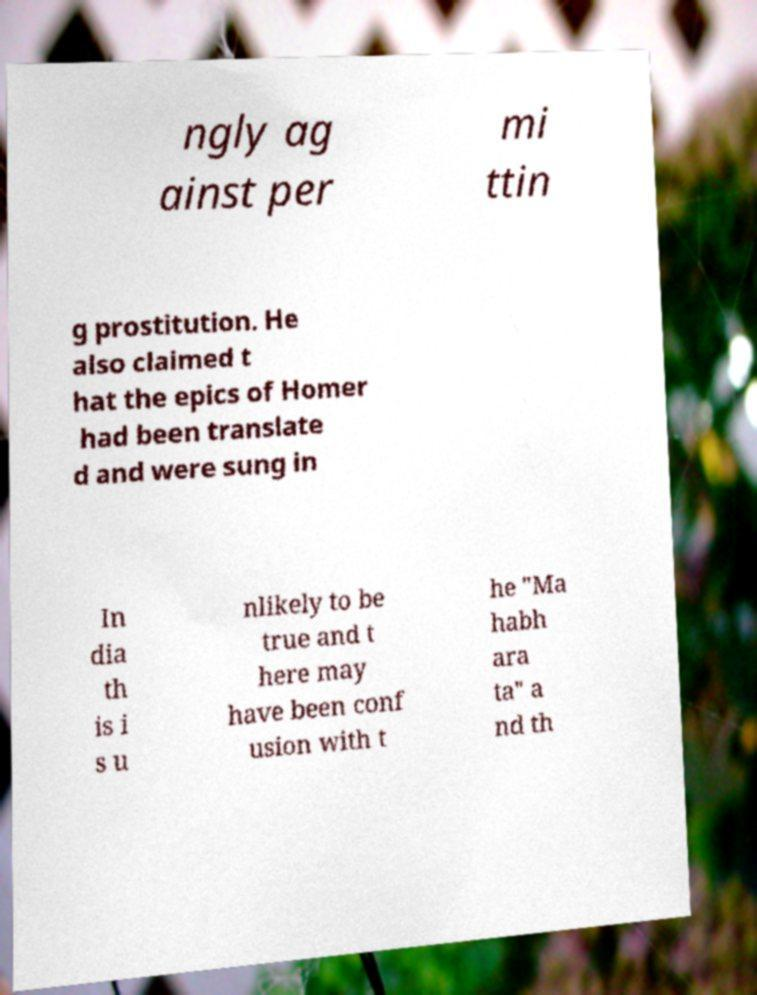Could you assist in decoding the text presented in this image and type it out clearly? ngly ag ainst per mi ttin g prostitution. He also claimed t hat the epics of Homer had been translate d and were sung in In dia th is i s u nlikely to be true and t here may have been conf usion with t he "Ma habh ara ta" a nd th 